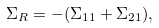<formula> <loc_0><loc_0><loc_500><loc_500>\Sigma _ { R } = - ( \Sigma _ { 1 1 } + \Sigma _ { 2 1 } ) ,</formula> 